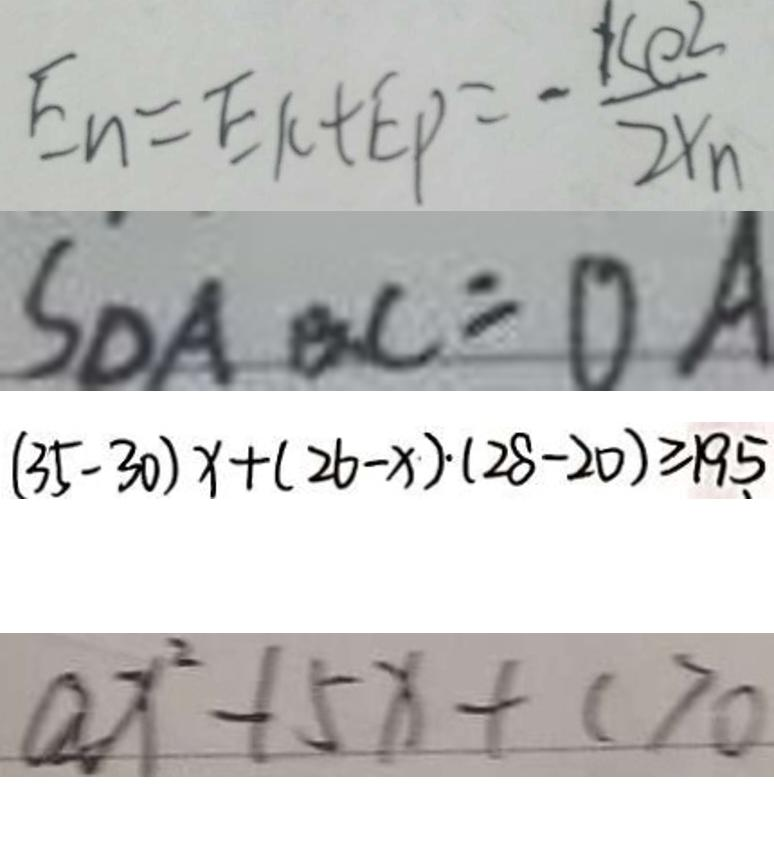Convert formula to latex. <formula><loc_0><loc_0><loc_500><loc_500>E _ { n } = E k + E P = - \frac { k e ^ { 2 } } { 2 Y _ { n } } 
 S _ { \Delta A B C } = O A 
 ( 3 5 - 3 0 ) x + ( 2 6 - x ) \cdot ( 2 8 - 2 0 ) \geq 1 9 5 
 a x ^ { 2 } - 1 5 x + c > 0</formula> 